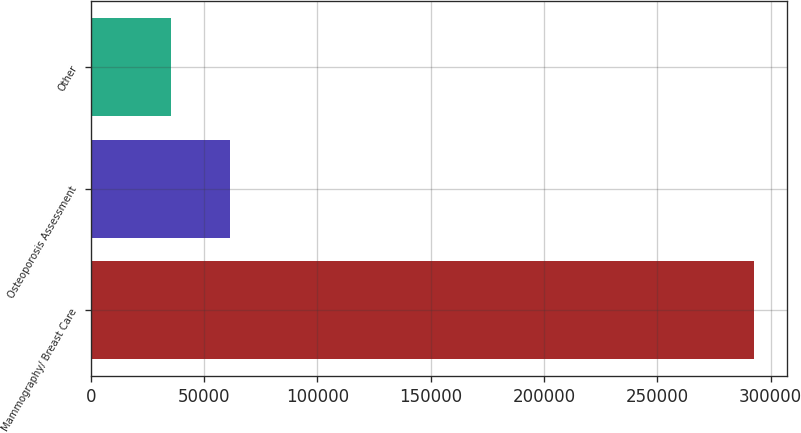Convert chart to OTSL. <chart><loc_0><loc_0><loc_500><loc_500><bar_chart><fcel>Mammography/ Breast Care<fcel>Osteoporosis Assessment<fcel>Other<nl><fcel>292773<fcel>61372.2<fcel>35661<nl></chart> 